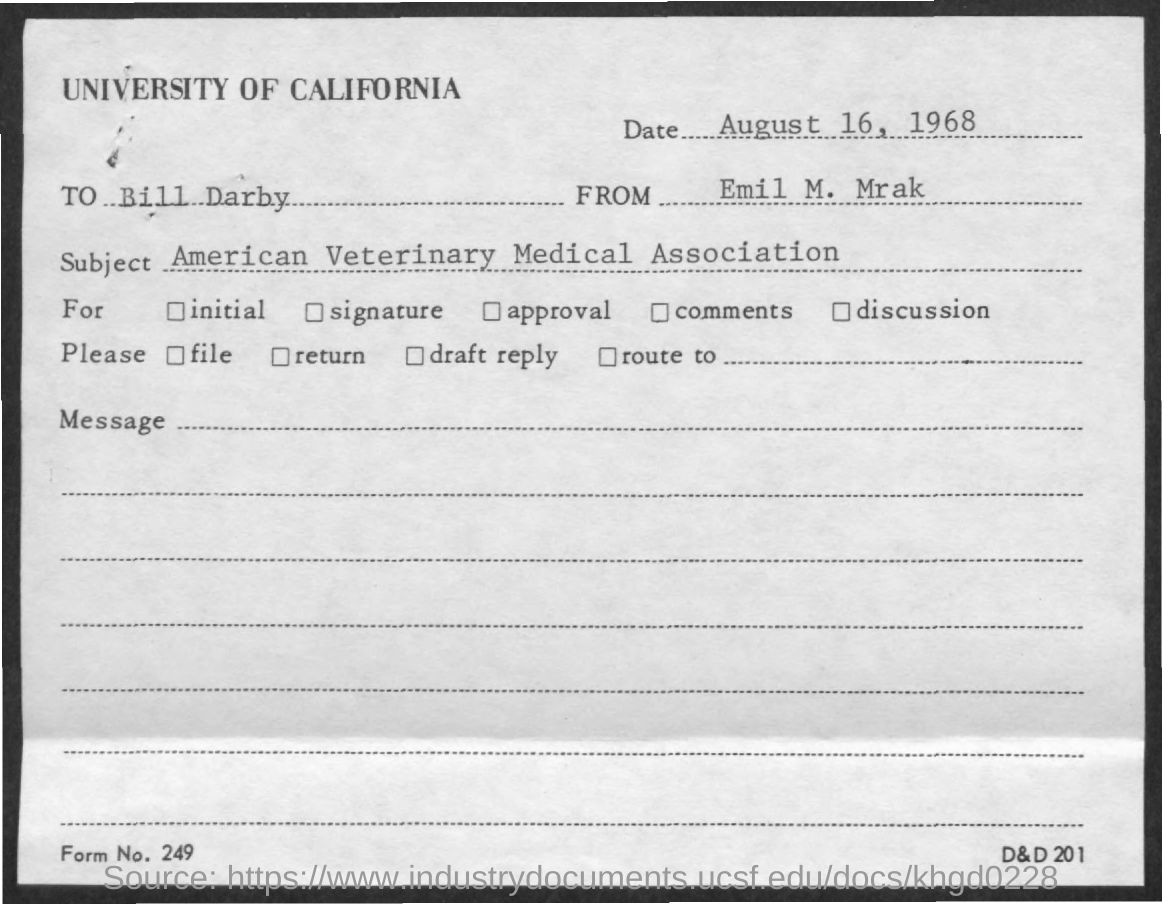When is the memorandum dated on ?
Keep it short and to the point. August 16, 1968. Who is the memorandum from ?
Provide a succinct answer. Emil M. Mrak. Who is the Memorandum Addressed to ?
Provide a succinct answer. Bill Darby. What is the Form Number ?
Offer a terse response. 249. 